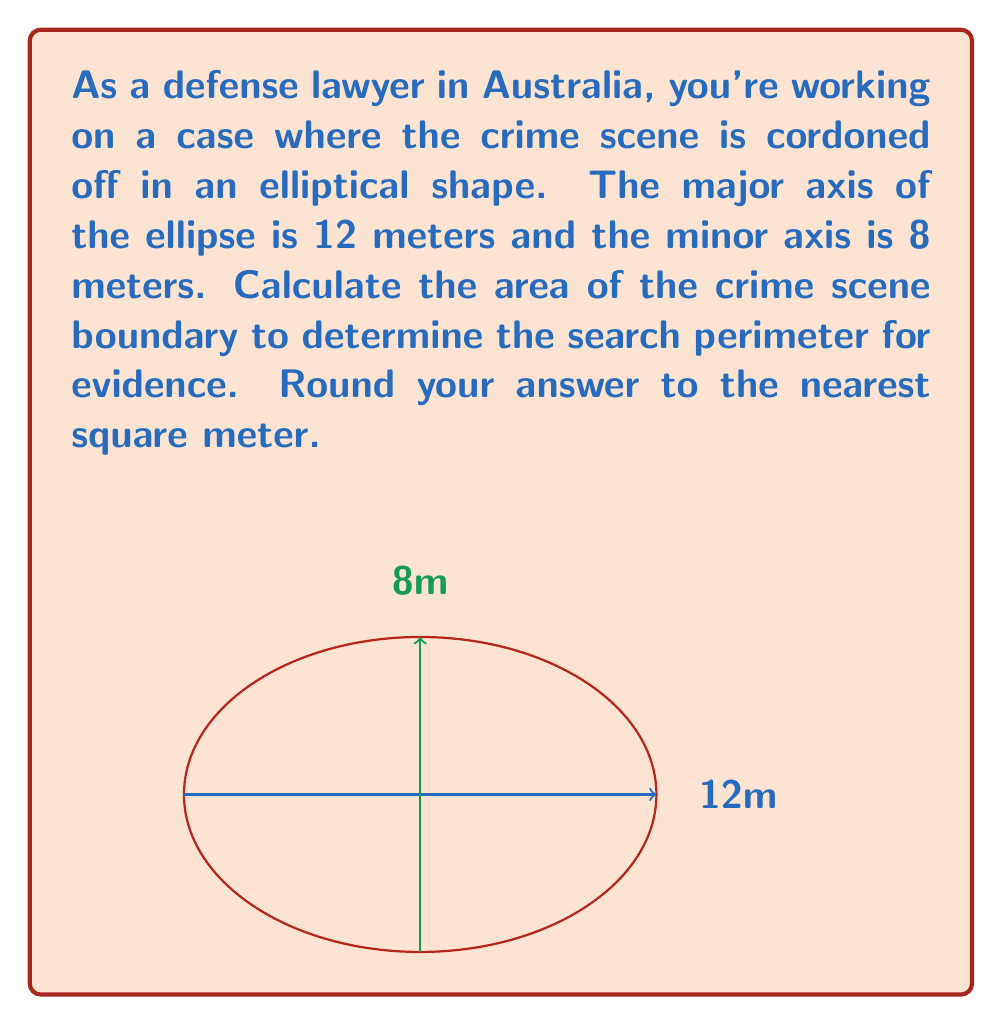Could you help me with this problem? To calculate the area of an ellipse, we use the formula:

$$A = \pi ab$$

Where:
$A$ = area of the ellipse
$a$ = half of the major axis (semi-major axis)
$b$ = half of the minor axis (semi-minor axis)

Given:
- Major axis = 12 meters
- Minor axis = 8 meters

Step 1: Calculate the semi-major and semi-minor axes
$a = 12 \div 2 = 6$ meters
$b = 8 \div 2 = 4$ meters

Step 2: Apply the formula
$$A = \pi ab$$
$$A = \pi \times 6 \times 4$$
$$A = 24\pi$$

Step 3: Calculate the result
$$A = 24 \times 3.14159... \approx 75.3982...$$

Step 4: Round to the nearest square meter
$$A \approx 75 \text{ m}^2$$
Answer: 75 m² 